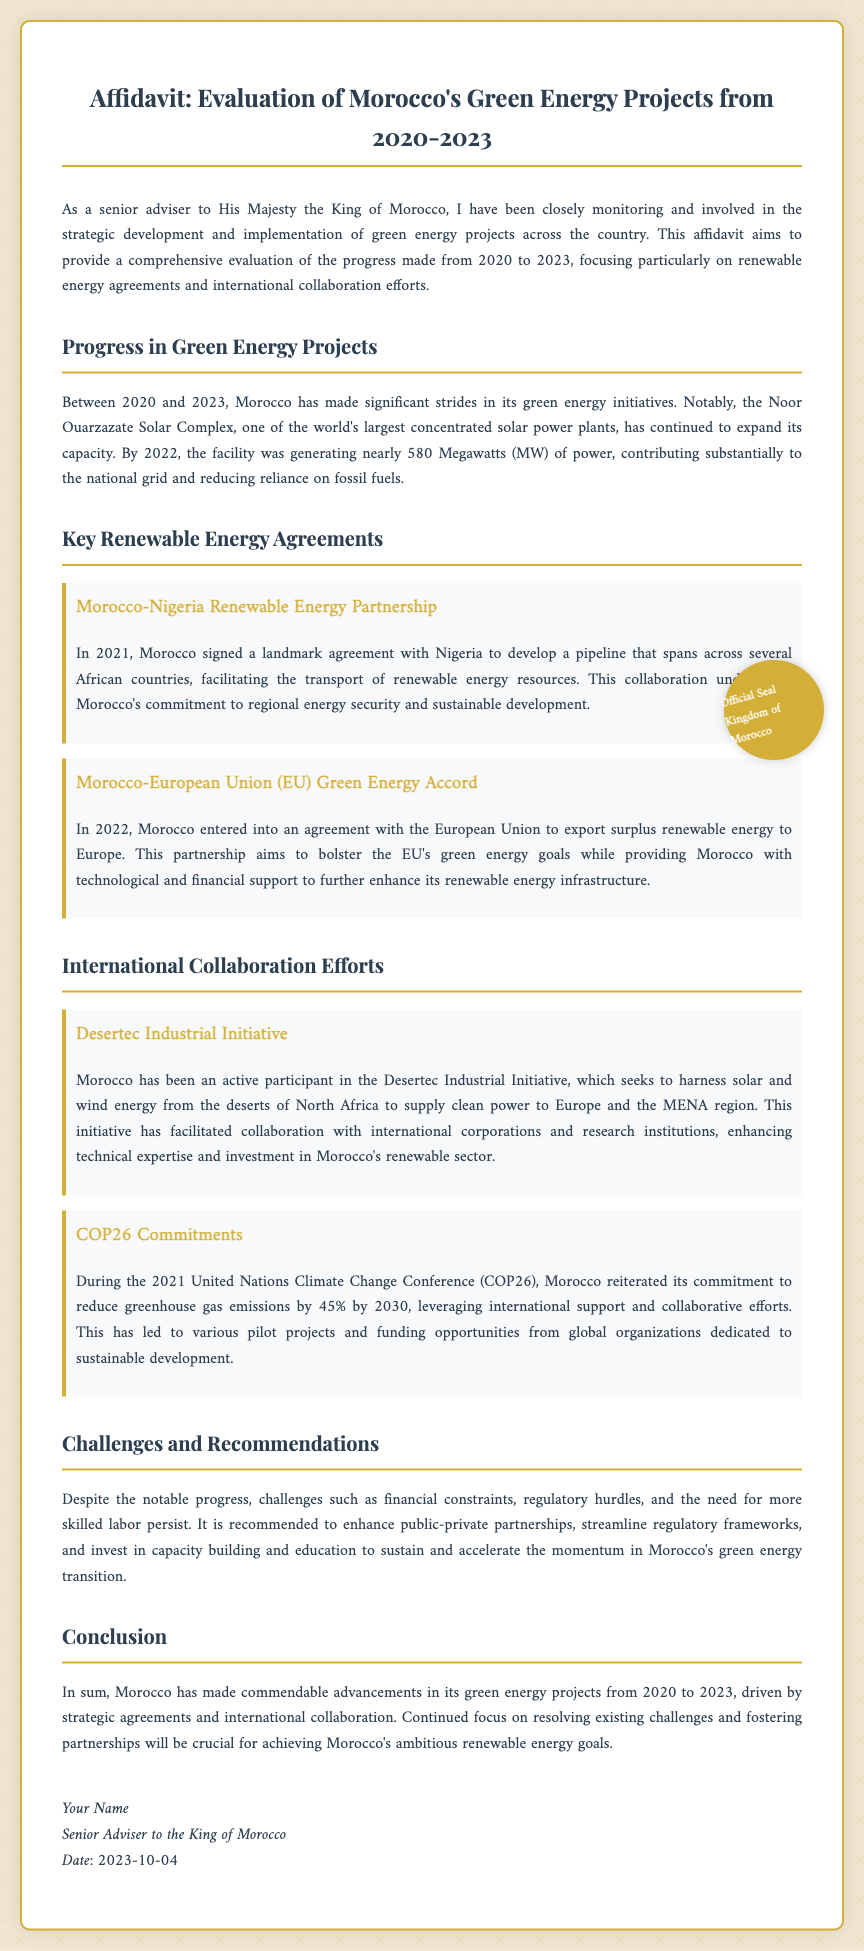what is the title of the affidavit? The title of the affidavit is clearly stated at the top of the document as "Affidavit: Evaluation of Morocco's Green Energy Projects from 2020-2023."
Answer: Affidavit: Evaluation of Morocco's Green Energy Projects from 2020-2023 who is the author of the affidavit? The author is identified within the document as "Senior Adviser to the King of Morocco."
Answer: Senior Adviser to the King of Morocco what is the capacity of the Noor Ouarzazate Solar Complex by 2022? The document states that by 2022, the Noor Ouarzazate Solar Complex was generating nearly 580 Megawatts (MW) of power.
Answer: nearly 580 Megawatts (MW) what year was the Morocco-Nigeria Renewable Energy Partnership signed? The affidavit indicates that the Morocco-Nigeria Renewable Energy Partnership was signed in 2021.
Answer: 2021 what commitment did Morocco make during COP26? The document states that during COP26, Morocco reiterated its commitment to reduce greenhouse gas emissions by 45% by 2030.
Answer: 45% by 2030 which international initiative is mentioned in the affidavit? The affidavit mentions the "Desertec Industrial Initiative."
Answer: Desertec Industrial Initiative what is the main focus of this affidavit? The primary focus of the affidavit is an evaluation of Morocco's green energy projects from 2020 to 2023, particularly on renewable energy agreements and international collaboration.
Answer: evaluation of Morocco's green energy projects what is recommended to address challenges in Morocco's green energy transition? The document recommends enhancing public-private partnerships as a way to address challenges in the energy transition.
Answer: enhancing public-private partnerships 